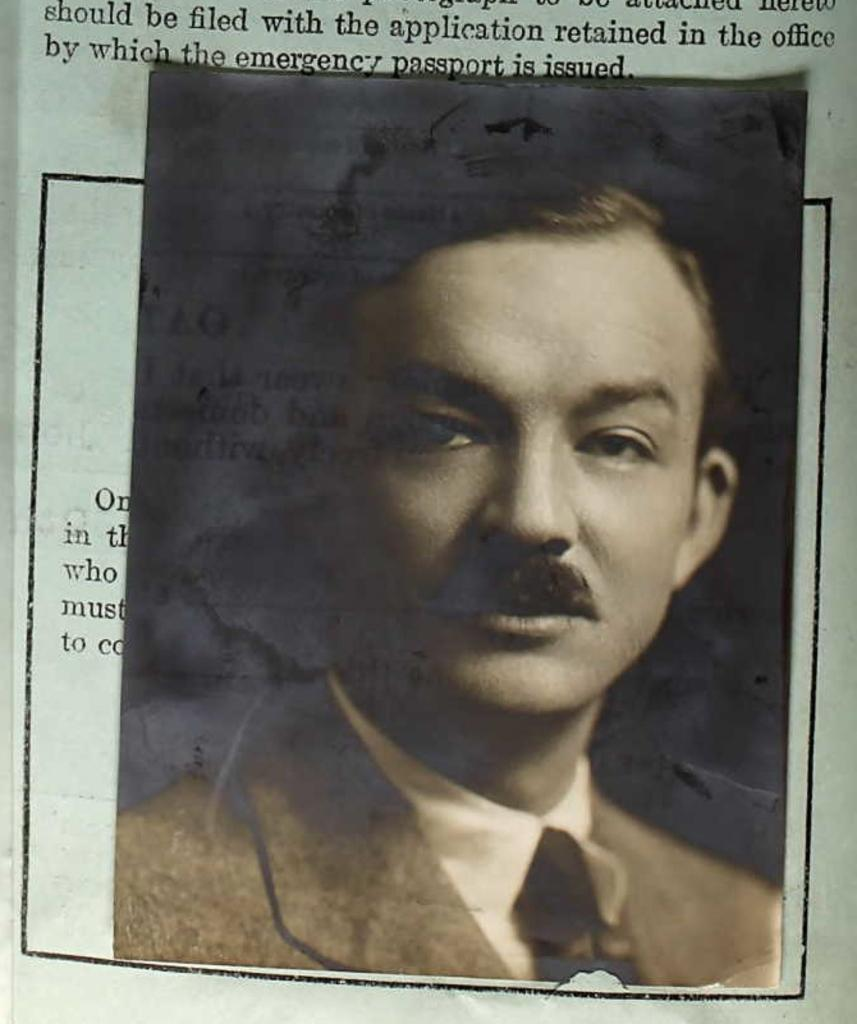What is the main subject of the image? The main subject of the image is a person's photo. Where is the photo placed in the image? The photo is placed on a book. What can be seen on the book besides the photo? There is writing on the book. What type of bait is used to catch fish in the image? There is no mention of fish or bait in the image; it features a person's photo placed on a book with writing. 